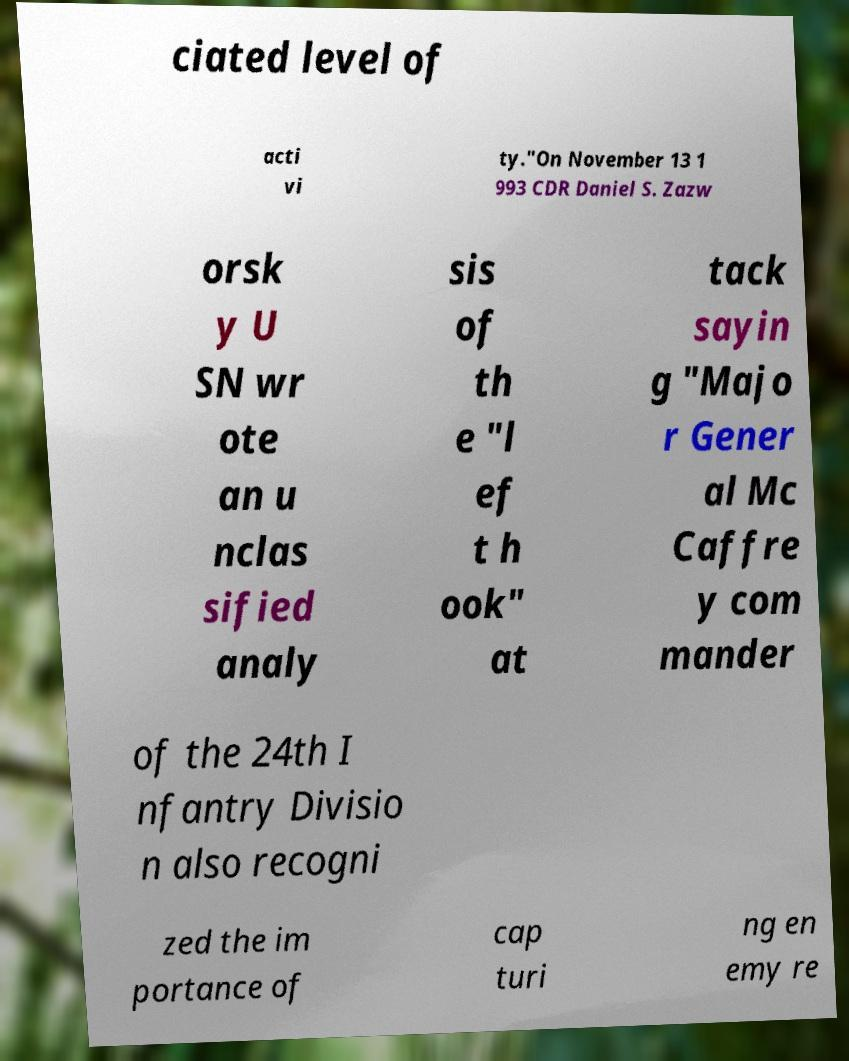For documentation purposes, I need the text within this image transcribed. Could you provide that? ciated level of acti vi ty."On November 13 1 993 CDR Daniel S. Zazw orsk y U SN wr ote an u nclas sified analy sis of th e "l ef t h ook" at tack sayin g "Majo r Gener al Mc Caffre y com mander of the 24th I nfantry Divisio n also recogni zed the im portance of cap turi ng en emy re 